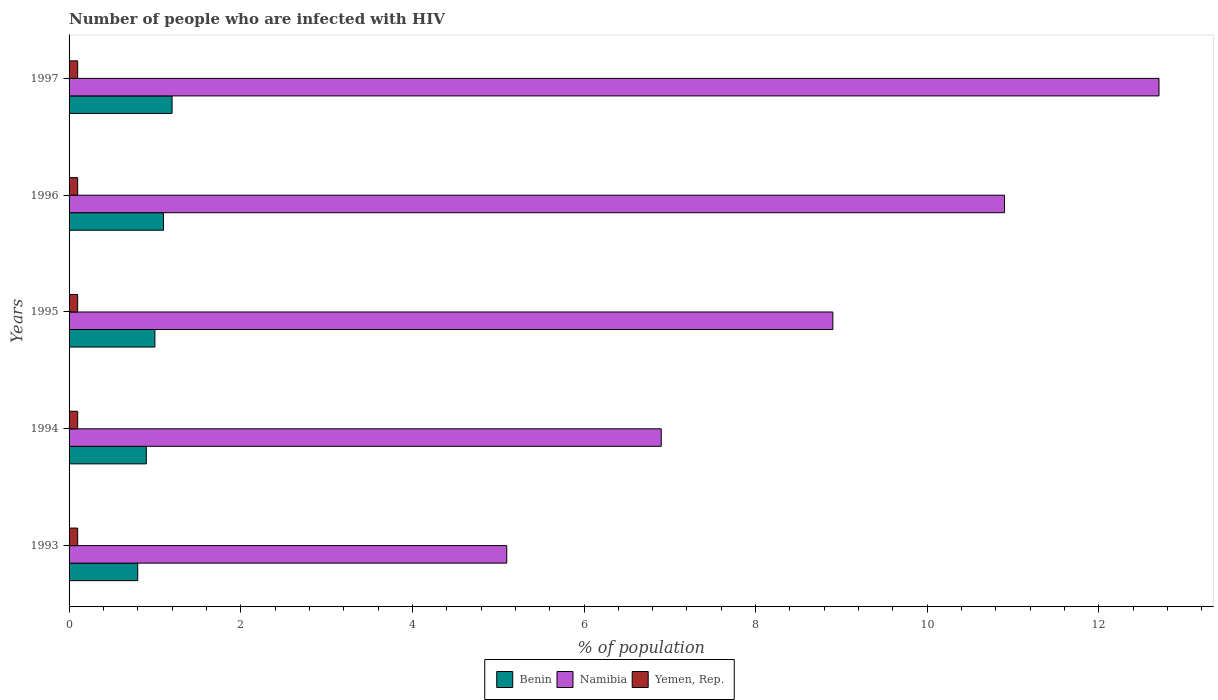How many different coloured bars are there?
Offer a very short reply. 3. How many groups of bars are there?
Give a very brief answer. 5. Are the number of bars per tick equal to the number of legend labels?
Provide a succinct answer. Yes. Are the number of bars on each tick of the Y-axis equal?
Your answer should be very brief. Yes. How many bars are there on the 3rd tick from the bottom?
Your answer should be very brief. 3. What is the label of the 5th group of bars from the top?
Your response must be concise. 1993. What is the percentage of HIV infected population in in Benin in 1993?
Your answer should be very brief. 0.8. In which year was the percentage of HIV infected population in in Namibia minimum?
Offer a very short reply. 1993. What is the total percentage of HIV infected population in in Namibia in the graph?
Ensure brevity in your answer.  44.5. What is the difference between the percentage of HIV infected population in in Namibia in 1993 and that in 1994?
Your answer should be very brief. -1.8. What is the difference between the percentage of HIV infected population in in Benin in 1994 and the percentage of HIV infected population in in Namibia in 1996?
Your answer should be compact. -10. What is the average percentage of HIV infected population in in Benin per year?
Offer a very short reply. 1. In how many years, is the percentage of HIV infected population in in Namibia greater than 12.8 %?
Your answer should be compact. 0. What is the ratio of the percentage of HIV infected population in in Namibia in 1993 to that in 1997?
Provide a short and direct response. 0.4. What is the difference between the highest and the second highest percentage of HIV infected population in in Yemen, Rep.?
Ensure brevity in your answer.  0. Is the sum of the percentage of HIV infected population in in Yemen, Rep. in 1996 and 1997 greater than the maximum percentage of HIV infected population in in Namibia across all years?
Your answer should be compact. No. What does the 2nd bar from the top in 1995 represents?
Keep it short and to the point. Namibia. What does the 2nd bar from the bottom in 1995 represents?
Your answer should be very brief. Namibia. Is it the case that in every year, the sum of the percentage of HIV infected population in in Benin and percentage of HIV infected population in in Namibia is greater than the percentage of HIV infected population in in Yemen, Rep.?
Keep it short and to the point. Yes. How many bars are there?
Give a very brief answer. 15. Are all the bars in the graph horizontal?
Give a very brief answer. Yes. How many years are there in the graph?
Your answer should be very brief. 5. What is the difference between two consecutive major ticks on the X-axis?
Your answer should be compact. 2. Are the values on the major ticks of X-axis written in scientific E-notation?
Ensure brevity in your answer.  No. How are the legend labels stacked?
Keep it short and to the point. Horizontal. What is the title of the graph?
Your response must be concise. Number of people who are infected with HIV. Does "Samoa" appear as one of the legend labels in the graph?
Your response must be concise. No. What is the label or title of the X-axis?
Provide a succinct answer. % of population. What is the % of population in Benin in 1993?
Keep it short and to the point. 0.8. What is the % of population of Namibia in 1993?
Provide a succinct answer. 5.1. What is the % of population in Yemen, Rep. in 1993?
Offer a terse response. 0.1. What is the % of population of Namibia in 1994?
Your answer should be very brief. 6.9. What is the % of population of Yemen, Rep. in 1994?
Make the answer very short. 0.1. What is the % of population of Benin in 1995?
Offer a terse response. 1. What is the % of population of Namibia in 1995?
Offer a very short reply. 8.9. What is the % of population of Yemen, Rep. in 1995?
Provide a succinct answer. 0.1. What is the % of population of Namibia in 1996?
Your answer should be compact. 10.9. What is the % of population in Benin in 1997?
Offer a terse response. 1.2. What is the % of population of Yemen, Rep. in 1997?
Your response must be concise. 0.1. Across all years, what is the maximum % of population of Benin?
Ensure brevity in your answer.  1.2. Across all years, what is the minimum % of population of Namibia?
Offer a terse response. 5.1. What is the total % of population of Namibia in the graph?
Make the answer very short. 44.5. What is the difference between the % of population of Yemen, Rep. in 1993 and that in 1994?
Make the answer very short. 0. What is the difference between the % of population of Namibia in 1993 and that in 1996?
Offer a terse response. -5.8. What is the difference between the % of population of Benin in 1994 and that in 1995?
Offer a terse response. -0.1. What is the difference between the % of population in Namibia in 1994 and that in 1995?
Your response must be concise. -2. What is the difference between the % of population in Yemen, Rep. in 1994 and that in 1997?
Your answer should be compact. 0. What is the difference between the % of population in Namibia in 1995 and that in 1996?
Provide a succinct answer. -2. What is the difference between the % of population in Namibia in 1995 and that in 1997?
Offer a very short reply. -3.8. What is the difference between the % of population of Benin in 1996 and that in 1997?
Keep it short and to the point. -0.1. What is the difference between the % of population of Yemen, Rep. in 1996 and that in 1997?
Provide a succinct answer. 0. What is the difference between the % of population of Benin in 1993 and the % of population of Namibia in 1994?
Your answer should be very brief. -6.1. What is the difference between the % of population in Benin in 1993 and the % of population in Yemen, Rep. in 1994?
Your response must be concise. 0.7. What is the difference between the % of population in Namibia in 1993 and the % of population in Yemen, Rep. in 1994?
Your answer should be compact. 5. What is the difference between the % of population of Benin in 1993 and the % of population of Yemen, Rep. in 1995?
Ensure brevity in your answer.  0.7. What is the difference between the % of population of Benin in 1993 and the % of population of Namibia in 1996?
Provide a succinct answer. -10.1. What is the difference between the % of population in Namibia in 1993 and the % of population in Yemen, Rep. in 1996?
Your response must be concise. 5. What is the difference between the % of population in Namibia in 1993 and the % of population in Yemen, Rep. in 1997?
Your answer should be compact. 5. What is the difference between the % of population of Benin in 1994 and the % of population of Namibia in 1995?
Keep it short and to the point. -8. What is the difference between the % of population in Benin in 1994 and the % of population in Yemen, Rep. in 1995?
Offer a very short reply. 0.8. What is the difference between the % of population of Namibia in 1994 and the % of population of Yemen, Rep. in 1995?
Your response must be concise. 6.8. What is the difference between the % of population of Benin in 1994 and the % of population of Namibia in 1996?
Offer a terse response. -10. What is the difference between the % of population in Benin in 1994 and the % of population in Yemen, Rep. in 1997?
Offer a terse response. 0.8. What is the difference between the % of population of Namibia in 1994 and the % of population of Yemen, Rep. in 1997?
Keep it short and to the point. 6.8. What is the difference between the % of population in Namibia in 1995 and the % of population in Yemen, Rep. in 1996?
Offer a very short reply. 8.8. What is the difference between the % of population of Namibia in 1995 and the % of population of Yemen, Rep. in 1997?
Your answer should be very brief. 8.8. What is the difference between the % of population of Benin in 1996 and the % of population of Namibia in 1997?
Your response must be concise. -11.6. What is the difference between the % of population of Benin in 1996 and the % of population of Yemen, Rep. in 1997?
Your answer should be very brief. 1. What is the average % of population of Benin per year?
Offer a very short reply. 1. In the year 1993, what is the difference between the % of population in Benin and % of population in Namibia?
Provide a short and direct response. -4.3. In the year 1993, what is the difference between the % of population in Benin and % of population in Yemen, Rep.?
Offer a terse response. 0.7. In the year 1993, what is the difference between the % of population in Namibia and % of population in Yemen, Rep.?
Keep it short and to the point. 5. In the year 1994, what is the difference between the % of population in Benin and % of population in Yemen, Rep.?
Give a very brief answer. 0.8. In the year 1995, what is the difference between the % of population in Benin and % of population in Yemen, Rep.?
Keep it short and to the point. 0.9. In the year 1995, what is the difference between the % of population in Namibia and % of population in Yemen, Rep.?
Your answer should be very brief. 8.8. In the year 1996, what is the difference between the % of population of Namibia and % of population of Yemen, Rep.?
Provide a short and direct response. 10.8. In the year 1997, what is the difference between the % of population of Benin and % of population of Yemen, Rep.?
Ensure brevity in your answer.  1.1. What is the ratio of the % of population in Namibia in 1993 to that in 1994?
Ensure brevity in your answer.  0.74. What is the ratio of the % of population in Namibia in 1993 to that in 1995?
Provide a succinct answer. 0.57. What is the ratio of the % of population of Benin in 1993 to that in 1996?
Give a very brief answer. 0.73. What is the ratio of the % of population in Namibia in 1993 to that in 1996?
Your answer should be compact. 0.47. What is the ratio of the % of population in Benin in 1993 to that in 1997?
Keep it short and to the point. 0.67. What is the ratio of the % of population in Namibia in 1993 to that in 1997?
Give a very brief answer. 0.4. What is the ratio of the % of population in Namibia in 1994 to that in 1995?
Make the answer very short. 0.78. What is the ratio of the % of population in Benin in 1994 to that in 1996?
Provide a succinct answer. 0.82. What is the ratio of the % of population of Namibia in 1994 to that in 1996?
Your answer should be compact. 0.63. What is the ratio of the % of population of Benin in 1994 to that in 1997?
Offer a very short reply. 0.75. What is the ratio of the % of population of Namibia in 1994 to that in 1997?
Your answer should be compact. 0.54. What is the ratio of the % of population in Benin in 1995 to that in 1996?
Make the answer very short. 0.91. What is the ratio of the % of population in Namibia in 1995 to that in 1996?
Your answer should be very brief. 0.82. What is the ratio of the % of population in Namibia in 1995 to that in 1997?
Keep it short and to the point. 0.7. What is the ratio of the % of population of Yemen, Rep. in 1995 to that in 1997?
Your answer should be very brief. 1. What is the ratio of the % of population of Namibia in 1996 to that in 1997?
Give a very brief answer. 0.86. What is the ratio of the % of population of Yemen, Rep. in 1996 to that in 1997?
Your answer should be very brief. 1. What is the difference between the highest and the second highest % of population of Namibia?
Your answer should be compact. 1.8. What is the difference between the highest and the second highest % of population in Yemen, Rep.?
Your response must be concise. 0. What is the difference between the highest and the lowest % of population of Benin?
Provide a short and direct response. 0.4. What is the difference between the highest and the lowest % of population in Namibia?
Provide a succinct answer. 7.6. What is the difference between the highest and the lowest % of population of Yemen, Rep.?
Keep it short and to the point. 0. 